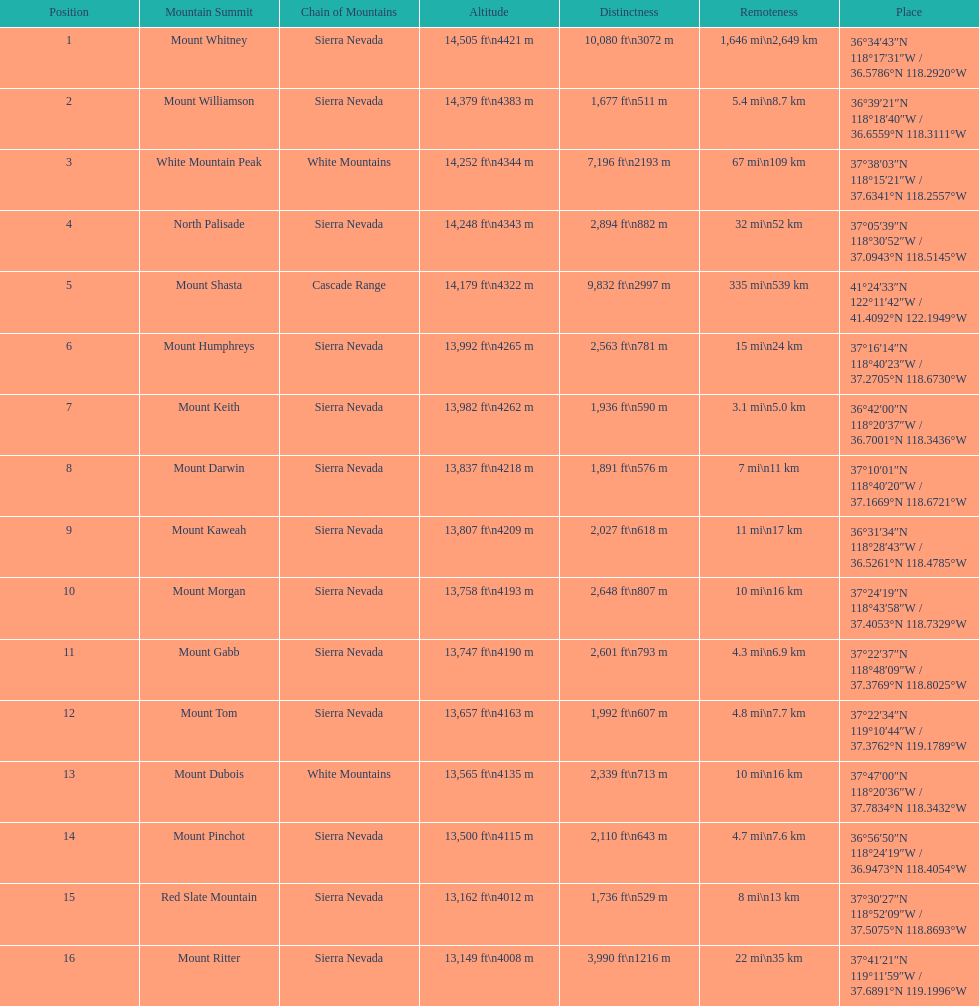Which mountain peak is no higher than 13,149 ft? Mount Ritter. 